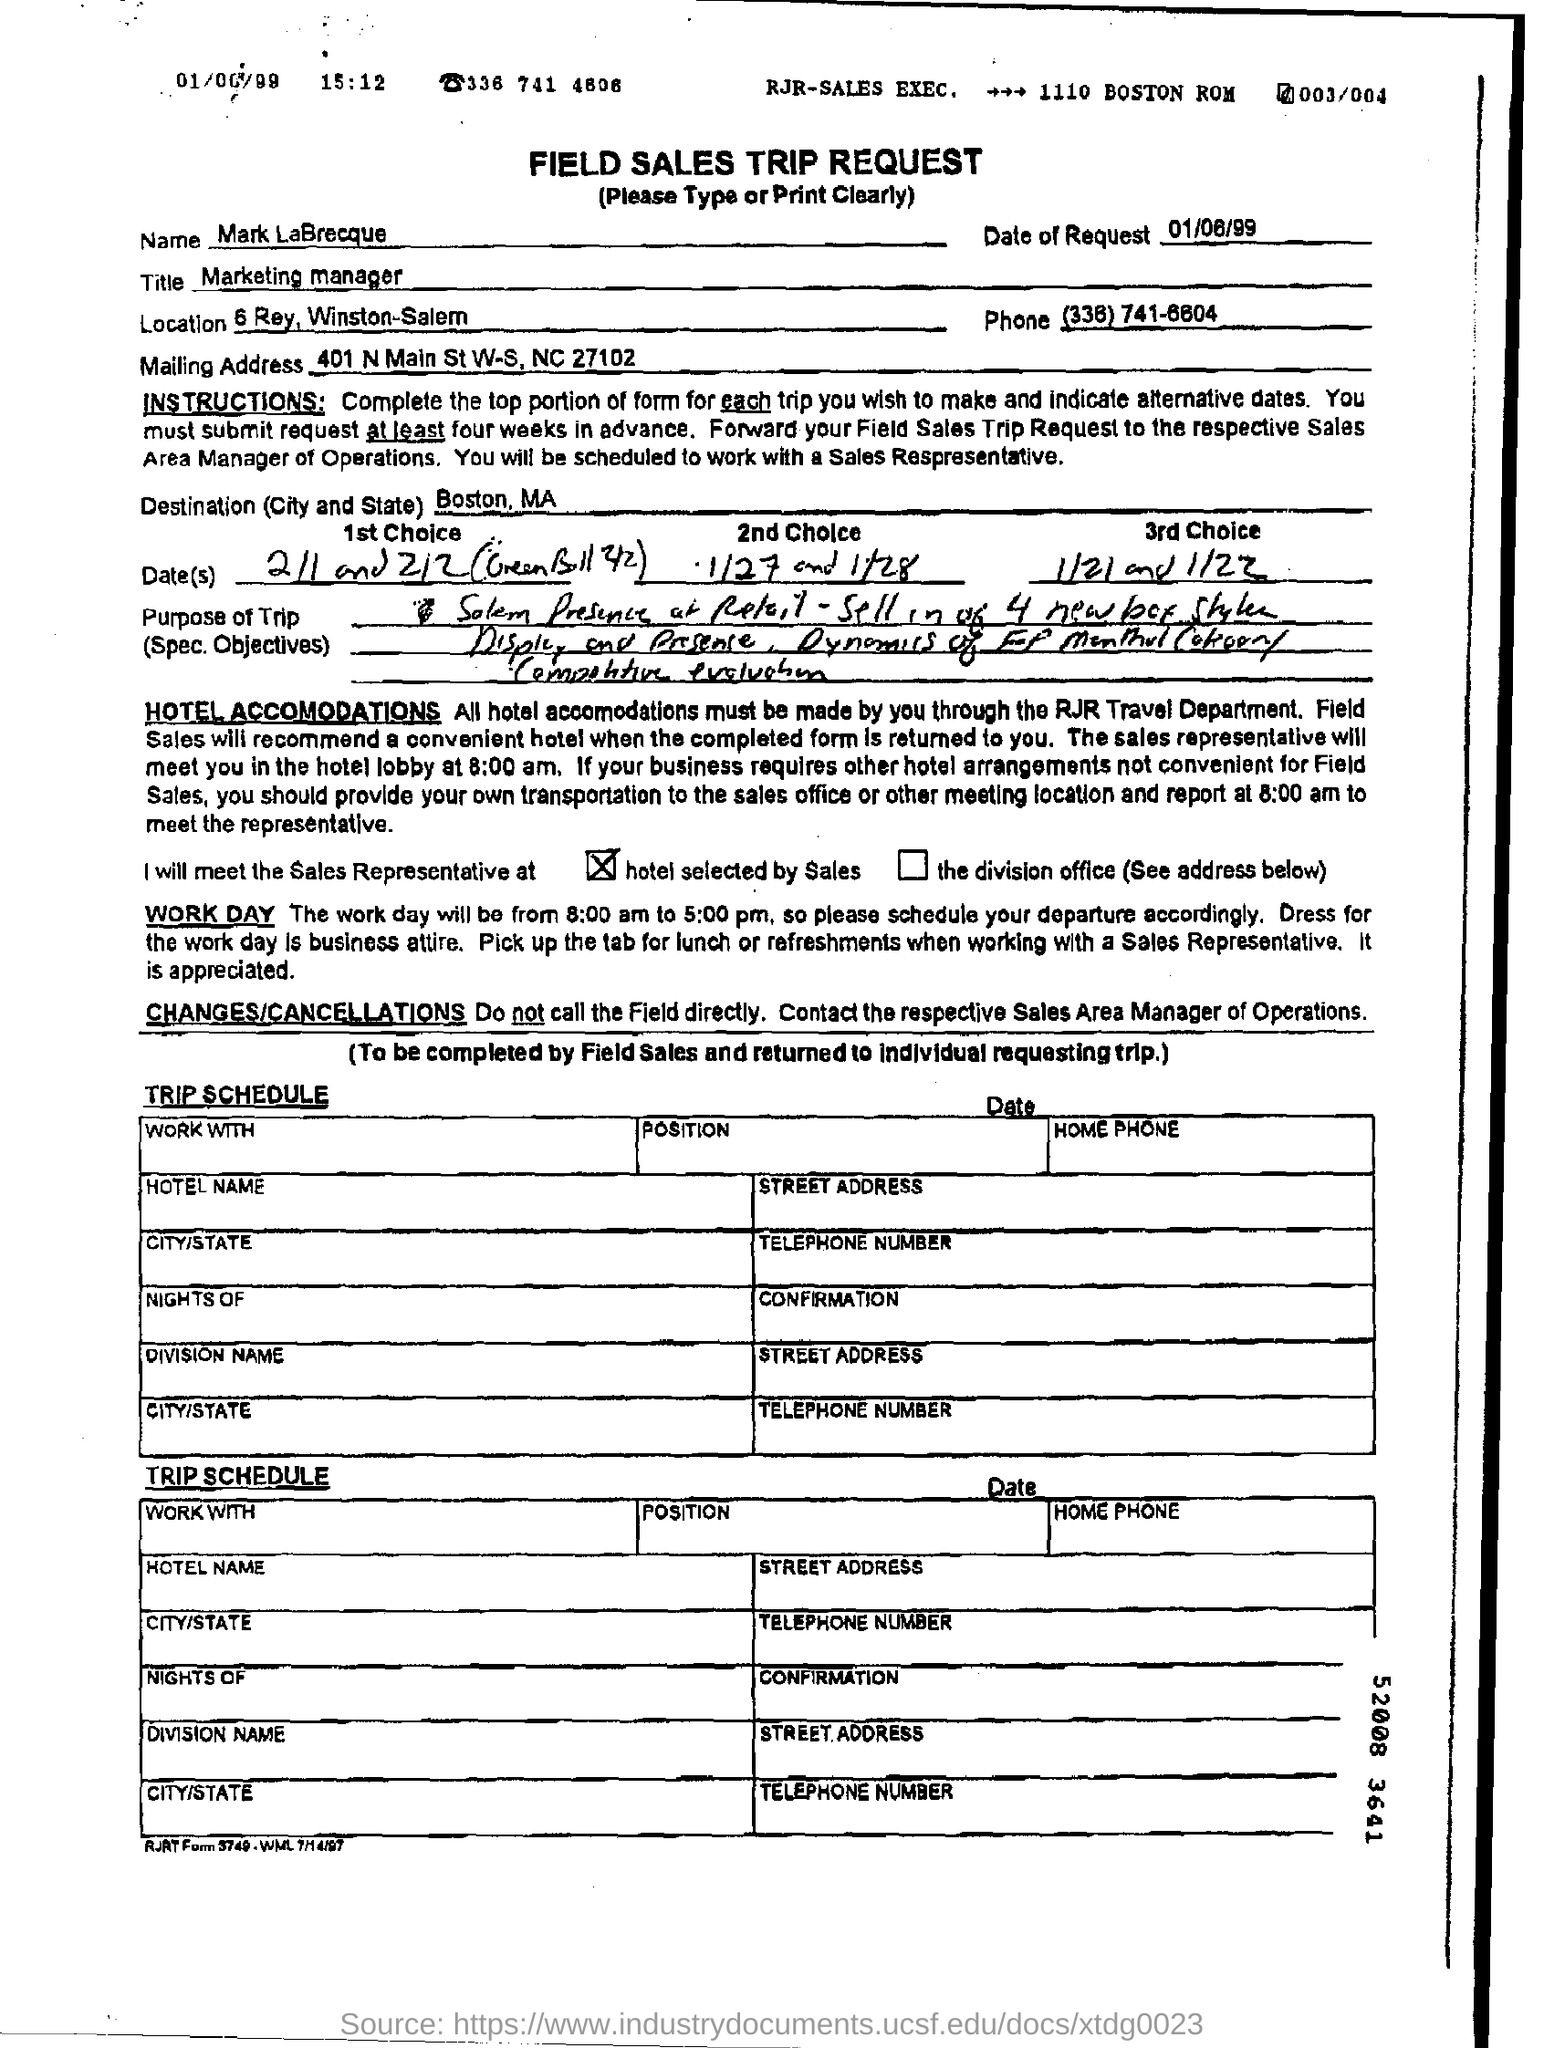Outline some significant characteristics in this image. The date of the request mentioned is June 1, 1999. The destination mentioned is Boston, Massachusetts. 